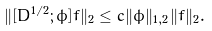<formula> <loc_0><loc_0><loc_500><loc_500>\| [ D ^ { 1 / 2 } ; \phi ] f \| _ { 2 } \leq c \| \phi \| _ { 1 , 2 } \| f \| _ { 2 } .</formula> 